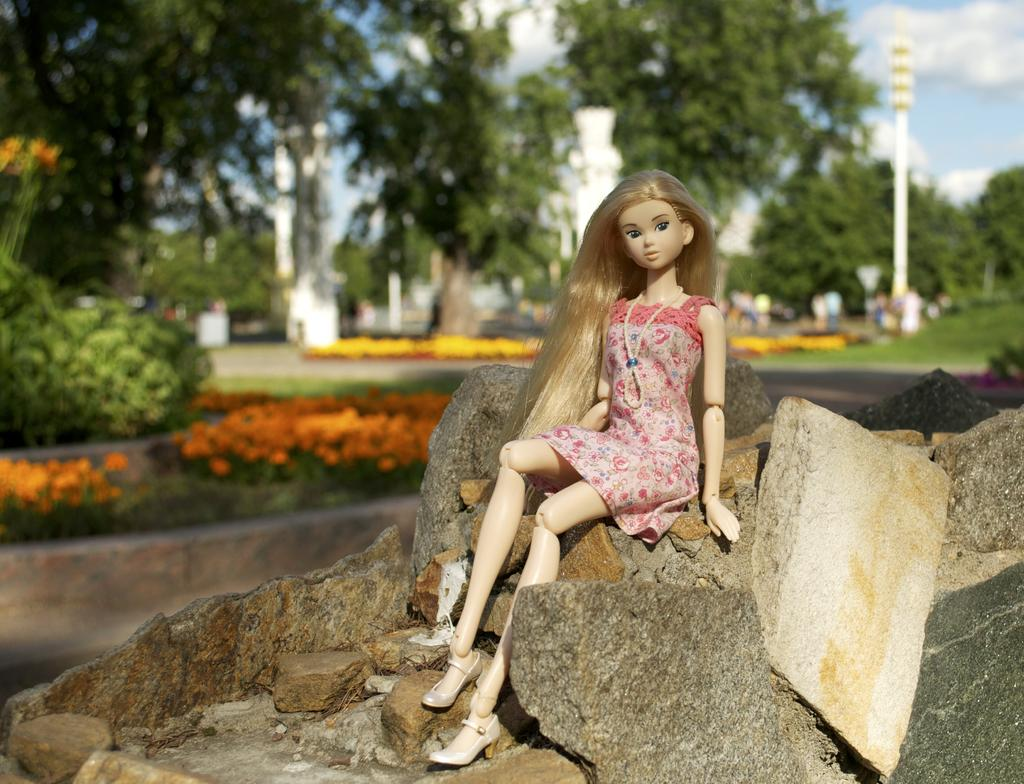What is the doll sitting on in the image? The doll is sitting on rocks in the image. What type of vegetation can be seen in the image? Plants, flowers, and trees are present in the image. What is the ground made of in the image? Grass is visible in the image. What structure can be seen in the image? There is a building in the image. What part of the natural environment is visible in the image? The sky is visible in the image. What type of trade is being conducted in the image? There is no indication of any trade being conducted in the image. What process is the doll undergoing while sitting on the rocks? The doll is not undergoing any process; it is simply sitting on the rocks. 